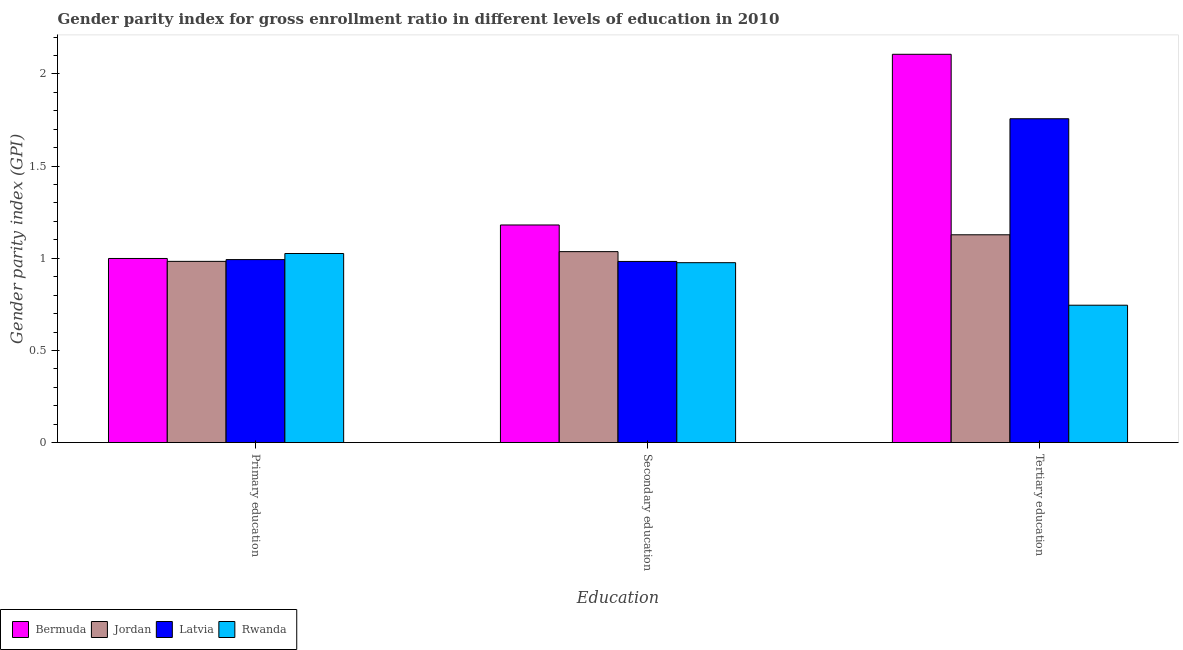How many groups of bars are there?
Give a very brief answer. 3. Are the number of bars per tick equal to the number of legend labels?
Give a very brief answer. Yes. Are the number of bars on each tick of the X-axis equal?
Make the answer very short. Yes. How many bars are there on the 1st tick from the left?
Ensure brevity in your answer.  4. What is the gender parity index in secondary education in Bermuda?
Provide a succinct answer. 1.18. Across all countries, what is the maximum gender parity index in tertiary education?
Give a very brief answer. 2.11. Across all countries, what is the minimum gender parity index in tertiary education?
Ensure brevity in your answer.  0.75. In which country was the gender parity index in secondary education maximum?
Your answer should be very brief. Bermuda. In which country was the gender parity index in tertiary education minimum?
Offer a terse response. Rwanda. What is the total gender parity index in tertiary education in the graph?
Make the answer very short. 5.74. What is the difference between the gender parity index in primary education in Jordan and that in Latvia?
Offer a terse response. -0.01. What is the difference between the gender parity index in secondary education in Jordan and the gender parity index in tertiary education in Rwanda?
Provide a succinct answer. 0.29. What is the average gender parity index in tertiary education per country?
Provide a succinct answer. 1.43. What is the difference between the gender parity index in tertiary education and gender parity index in secondary education in Latvia?
Offer a very short reply. 0.77. What is the ratio of the gender parity index in primary education in Latvia to that in Bermuda?
Provide a succinct answer. 0.99. Is the gender parity index in tertiary education in Bermuda less than that in Latvia?
Your response must be concise. No. Is the difference between the gender parity index in primary education in Rwanda and Latvia greater than the difference between the gender parity index in tertiary education in Rwanda and Latvia?
Offer a terse response. Yes. What is the difference between the highest and the second highest gender parity index in primary education?
Your response must be concise. 0.03. What is the difference between the highest and the lowest gender parity index in secondary education?
Provide a succinct answer. 0.2. Is the sum of the gender parity index in tertiary education in Jordan and Bermuda greater than the maximum gender parity index in secondary education across all countries?
Your response must be concise. Yes. What does the 3rd bar from the left in Primary education represents?
Your answer should be compact. Latvia. What does the 4th bar from the right in Tertiary education represents?
Provide a succinct answer. Bermuda. How many bars are there?
Your response must be concise. 12. Are all the bars in the graph horizontal?
Provide a short and direct response. No. What is the difference between two consecutive major ticks on the Y-axis?
Your response must be concise. 0.5. Are the values on the major ticks of Y-axis written in scientific E-notation?
Your response must be concise. No. Does the graph contain any zero values?
Offer a very short reply. No. Does the graph contain grids?
Your answer should be very brief. No. Where does the legend appear in the graph?
Give a very brief answer. Bottom left. What is the title of the graph?
Offer a very short reply. Gender parity index for gross enrollment ratio in different levels of education in 2010. What is the label or title of the X-axis?
Offer a terse response. Education. What is the label or title of the Y-axis?
Keep it short and to the point. Gender parity index (GPI). What is the Gender parity index (GPI) of Bermuda in Primary education?
Ensure brevity in your answer.  1. What is the Gender parity index (GPI) in Jordan in Primary education?
Your response must be concise. 0.98. What is the Gender parity index (GPI) of Latvia in Primary education?
Ensure brevity in your answer.  0.99. What is the Gender parity index (GPI) in Rwanda in Primary education?
Offer a very short reply. 1.03. What is the Gender parity index (GPI) in Bermuda in Secondary education?
Give a very brief answer. 1.18. What is the Gender parity index (GPI) in Jordan in Secondary education?
Your answer should be compact. 1.04. What is the Gender parity index (GPI) in Latvia in Secondary education?
Keep it short and to the point. 0.98. What is the Gender parity index (GPI) in Rwanda in Secondary education?
Offer a terse response. 0.98. What is the Gender parity index (GPI) in Bermuda in Tertiary education?
Your answer should be very brief. 2.11. What is the Gender parity index (GPI) in Jordan in Tertiary education?
Provide a succinct answer. 1.13. What is the Gender parity index (GPI) of Latvia in Tertiary education?
Your response must be concise. 1.76. What is the Gender parity index (GPI) of Rwanda in Tertiary education?
Provide a short and direct response. 0.75. Across all Education, what is the maximum Gender parity index (GPI) of Bermuda?
Give a very brief answer. 2.11. Across all Education, what is the maximum Gender parity index (GPI) of Jordan?
Keep it short and to the point. 1.13. Across all Education, what is the maximum Gender parity index (GPI) of Latvia?
Your answer should be very brief. 1.76. Across all Education, what is the maximum Gender parity index (GPI) in Rwanda?
Offer a very short reply. 1.03. Across all Education, what is the minimum Gender parity index (GPI) in Bermuda?
Your response must be concise. 1. Across all Education, what is the minimum Gender parity index (GPI) in Jordan?
Keep it short and to the point. 0.98. Across all Education, what is the minimum Gender parity index (GPI) in Latvia?
Offer a terse response. 0.98. Across all Education, what is the minimum Gender parity index (GPI) in Rwanda?
Offer a very short reply. 0.75. What is the total Gender parity index (GPI) of Bermuda in the graph?
Your answer should be very brief. 4.29. What is the total Gender parity index (GPI) of Jordan in the graph?
Your response must be concise. 3.15. What is the total Gender parity index (GPI) in Latvia in the graph?
Ensure brevity in your answer.  3.73. What is the total Gender parity index (GPI) of Rwanda in the graph?
Keep it short and to the point. 2.75. What is the difference between the Gender parity index (GPI) of Bermuda in Primary education and that in Secondary education?
Your answer should be very brief. -0.18. What is the difference between the Gender parity index (GPI) in Jordan in Primary education and that in Secondary education?
Your answer should be very brief. -0.05. What is the difference between the Gender parity index (GPI) of Latvia in Primary education and that in Secondary education?
Your answer should be compact. 0.01. What is the difference between the Gender parity index (GPI) in Rwanda in Primary education and that in Secondary education?
Keep it short and to the point. 0.05. What is the difference between the Gender parity index (GPI) of Bermuda in Primary education and that in Tertiary education?
Your response must be concise. -1.11. What is the difference between the Gender parity index (GPI) of Jordan in Primary education and that in Tertiary education?
Your answer should be very brief. -0.14. What is the difference between the Gender parity index (GPI) in Latvia in Primary education and that in Tertiary education?
Offer a very short reply. -0.76. What is the difference between the Gender parity index (GPI) in Rwanda in Primary education and that in Tertiary education?
Your answer should be very brief. 0.28. What is the difference between the Gender parity index (GPI) in Bermuda in Secondary education and that in Tertiary education?
Provide a succinct answer. -0.93. What is the difference between the Gender parity index (GPI) of Jordan in Secondary education and that in Tertiary education?
Your response must be concise. -0.09. What is the difference between the Gender parity index (GPI) in Latvia in Secondary education and that in Tertiary education?
Ensure brevity in your answer.  -0.77. What is the difference between the Gender parity index (GPI) in Rwanda in Secondary education and that in Tertiary education?
Provide a succinct answer. 0.23. What is the difference between the Gender parity index (GPI) in Bermuda in Primary education and the Gender parity index (GPI) in Jordan in Secondary education?
Make the answer very short. -0.04. What is the difference between the Gender parity index (GPI) of Bermuda in Primary education and the Gender parity index (GPI) of Latvia in Secondary education?
Give a very brief answer. 0.02. What is the difference between the Gender parity index (GPI) in Bermuda in Primary education and the Gender parity index (GPI) in Rwanda in Secondary education?
Make the answer very short. 0.02. What is the difference between the Gender parity index (GPI) in Jordan in Primary education and the Gender parity index (GPI) in Rwanda in Secondary education?
Your answer should be compact. 0.01. What is the difference between the Gender parity index (GPI) of Latvia in Primary education and the Gender parity index (GPI) of Rwanda in Secondary education?
Your response must be concise. 0.02. What is the difference between the Gender parity index (GPI) in Bermuda in Primary education and the Gender parity index (GPI) in Jordan in Tertiary education?
Offer a very short reply. -0.13. What is the difference between the Gender parity index (GPI) in Bermuda in Primary education and the Gender parity index (GPI) in Latvia in Tertiary education?
Keep it short and to the point. -0.76. What is the difference between the Gender parity index (GPI) in Bermuda in Primary education and the Gender parity index (GPI) in Rwanda in Tertiary education?
Give a very brief answer. 0.25. What is the difference between the Gender parity index (GPI) in Jordan in Primary education and the Gender parity index (GPI) in Latvia in Tertiary education?
Offer a very short reply. -0.77. What is the difference between the Gender parity index (GPI) of Jordan in Primary education and the Gender parity index (GPI) of Rwanda in Tertiary education?
Your answer should be compact. 0.24. What is the difference between the Gender parity index (GPI) of Latvia in Primary education and the Gender parity index (GPI) of Rwanda in Tertiary education?
Offer a terse response. 0.25. What is the difference between the Gender parity index (GPI) of Bermuda in Secondary education and the Gender parity index (GPI) of Jordan in Tertiary education?
Make the answer very short. 0.05. What is the difference between the Gender parity index (GPI) in Bermuda in Secondary education and the Gender parity index (GPI) in Latvia in Tertiary education?
Offer a terse response. -0.58. What is the difference between the Gender parity index (GPI) of Bermuda in Secondary education and the Gender parity index (GPI) of Rwanda in Tertiary education?
Provide a succinct answer. 0.44. What is the difference between the Gender parity index (GPI) in Jordan in Secondary education and the Gender parity index (GPI) in Latvia in Tertiary education?
Your response must be concise. -0.72. What is the difference between the Gender parity index (GPI) in Jordan in Secondary education and the Gender parity index (GPI) in Rwanda in Tertiary education?
Your answer should be compact. 0.29. What is the difference between the Gender parity index (GPI) in Latvia in Secondary education and the Gender parity index (GPI) in Rwanda in Tertiary education?
Your answer should be compact. 0.24. What is the average Gender parity index (GPI) of Bermuda per Education?
Provide a short and direct response. 1.43. What is the average Gender parity index (GPI) in Jordan per Education?
Your answer should be very brief. 1.05. What is the average Gender parity index (GPI) in Latvia per Education?
Your answer should be very brief. 1.24. What is the average Gender parity index (GPI) in Rwanda per Education?
Offer a very short reply. 0.92. What is the difference between the Gender parity index (GPI) in Bermuda and Gender parity index (GPI) in Jordan in Primary education?
Provide a succinct answer. 0.02. What is the difference between the Gender parity index (GPI) in Bermuda and Gender parity index (GPI) in Latvia in Primary education?
Offer a terse response. 0.01. What is the difference between the Gender parity index (GPI) of Bermuda and Gender parity index (GPI) of Rwanda in Primary education?
Provide a short and direct response. -0.03. What is the difference between the Gender parity index (GPI) in Jordan and Gender parity index (GPI) in Latvia in Primary education?
Offer a very short reply. -0.01. What is the difference between the Gender parity index (GPI) in Jordan and Gender parity index (GPI) in Rwanda in Primary education?
Ensure brevity in your answer.  -0.04. What is the difference between the Gender parity index (GPI) of Latvia and Gender parity index (GPI) of Rwanda in Primary education?
Offer a terse response. -0.03. What is the difference between the Gender parity index (GPI) in Bermuda and Gender parity index (GPI) in Jordan in Secondary education?
Make the answer very short. 0.14. What is the difference between the Gender parity index (GPI) in Bermuda and Gender parity index (GPI) in Latvia in Secondary education?
Offer a very short reply. 0.2. What is the difference between the Gender parity index (GPI) in Bermuda and Gender parity index (GPI) in Rwanda in Secondary education?
Your answer should be very brief. 0.2. What is the difference between the Gender parity index (GPI) of Jordan and Gender parity index (GPI) of Latvia in Secondary education?
Make the answer very short. 0.05. What is the difference between the Gender parity index (GPI) of Jordan and Gender parity index (GPI) of Rwanda in Secondary education?
Keep it short and to the point. 0.06. What is the difference between the Gender parity index (GPI) of Latvia and Gender parity index (GPI) of Rwanda in Secondary education?
Your answer should be compact. 0.01. What is the difference between the Gender parity index (GPI) in Bermuda and Gender parity index (GPI) in Jordan in Tertiary education?
Ensure brevity in your answer.  0.98. What is the difference between the Gender parity index (GPI) of Bermuda and Gender parity index (GPI) of Latvia in Tertiary education?
Provide a succinct answer. 0.35. What is the difference between the Gender parity index (GPI) of Bermuda and Gender parity index (GPI) of Rwanda in Tertiary education?
Your answer should be very brief. 1.36. What is the difference between the Gender parity index (GPI) in Jordan and Gender parity index (GPI) in Latvia in Tertiary education?
Keep it short and to the point. -0.63. What is the difference between the Gender parity index (GPI) of Jordan and Gender parity index (GPI) of Rwanda in Tertiary education?
Provide a succinct answer. 0.38. What is the difference between the Gender parity index (GPI) in Latvia and Gender parity index (GPI) in Rwanda in Tertiary education?
Provide a succinct answer. 1.01. What is the ratio of the Gender parity index (GPI) of Bermuda in Primary education to that in Secondary education?
Make the answer very short. 0.85. What is the ratio of the Gender parity index (GPI) in Jordan in Primary education to that in Secondary education?
Provide a succinct answer. 0.95. What is the ratio of the Gender parity index (GPI) in Latvia in Primary education to that in Secondary education?
Provide a short and direct response. 1.01. What is the ratio of the Gender parity index (GPI) in Rwanda in Primary education to that in Secondary education?
Your answer should be very brief. 1.05. What is the ratio of the Gender parity index (GPI) of Bermuda in Primary education to that in Tertiary education?
Provide a short and direct response. 0.47. What is the ratio of the Gender parity index (GPI) in Jordan in Primary education to that in Tertiary education?
Provide a short and direct response. 0.87. What is the ratio of the Gender parity index (GPI) of Latvia in Primary education to that in Tertiary education?
Give a very brief answer. 0.57. What is the ratio of the Gender parity index (GPI) in Rwanda in Primary education to that in Tertiary education?
Give a very brief answer. 1.38. What is the ratio of the Gender parity index (GPI) in Bermuda in Secondary education to that in Tertiary education?
Your answer should be very brief. 0.56. What is the ratio of the Gender parity index (GPI) of Jordan in Secondary education to that in Tertiary education?
Ensure brevity in your answer.  0.92. What is the ratio of the Gender parity index (GPI) in Latvia in Secondary education to that in Tertiary education?
Your answer should be compact. 0.56. What is the ratio of the Gender parity index (GPI) of Rwanda in Secondary education to that in Tertiary education?
Provide a succinct answer. 1.31. What is the difference between the highest and the second highest Gender parity index (GPI) of Bermuda?
Your answer should be compact. 0.93. What is the difference between the highest and the second highest Gender parity index (GPI) of Jordan?
Make the answer very short. 0.09. What is the difference between the highest and the second highest Gender parity index (GPI) of Latvia?
Provide a short and direct response. 0.76. What is the difference between the highest and the second highest Gender parity index (GPI) in Rwanda?
Your answer should be compact. 0.05. What is the difference between the highest and the lowest Gender parity index (GPI) of Bermuda?
Give a very brief answer. 1.11. What is the difference between the highest and the lowest Gender parity index (GPI) in Jordan?
Make the answer very short. 0.14. What is the difference between the highest and the lowest Gender parity index (GPI) in Latvia?
Your response must be concise. 0.77. What is the difference between the highest and the lowest Gender parity index (GPI) in Rwanda?
Your answer should be very brief. 0.28. 